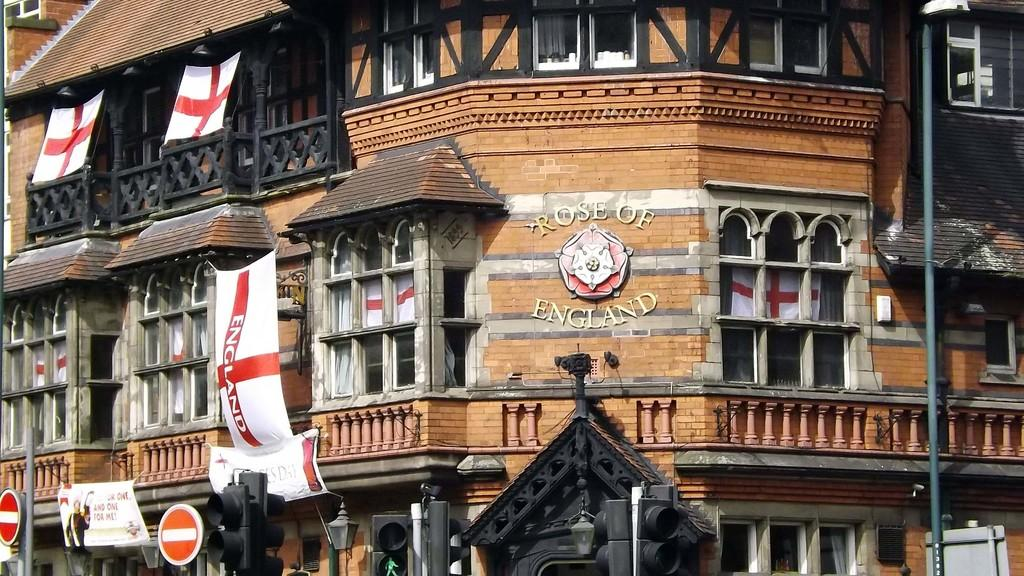<image>
Provide a brief description of the given image. Words outside of a brown building which says "Rose of England". 